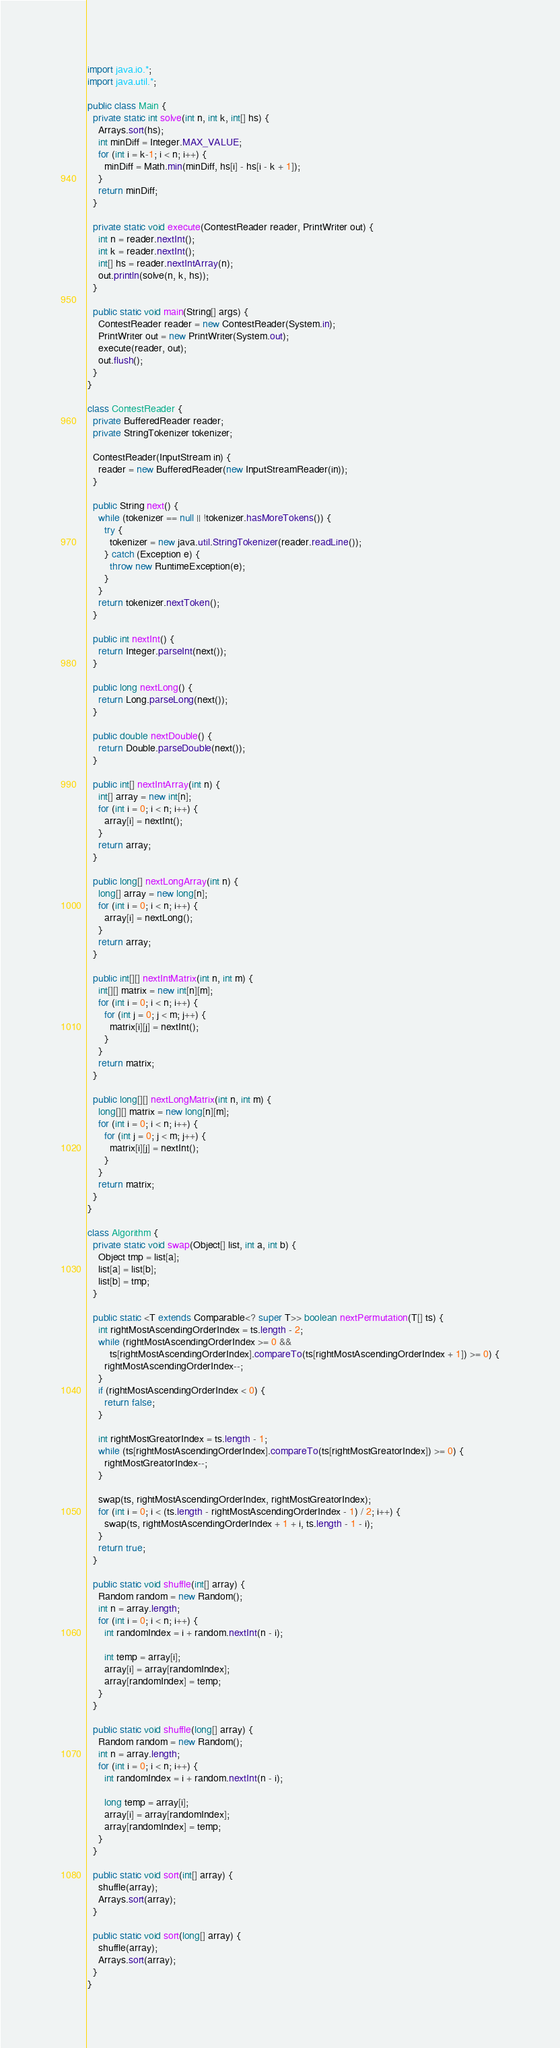Convert code to text. <code><loc_0><loc_0><loc_500><loc_500><_Java_>import java.io.*;
import java.util.*;

public class Main {
  private static int solve(int n, int k, int[] hs) {
    Arrays.sort(hs);
    int minDiff = Integer.MAX_VALUE;
    for (int i = k-1; i < n; i++) {
      minDiff = Math.min(minDiff, hs[i] - hs[i - k + 1]);
    }
    return minDiff;
  }
  
  private static void execute(ContestReader reader, PrintWriter out) {
    int n = reader.nextInt();
    int k = reader.nextInt();
    int[] hs = reader.nextIntArray(n);
    out.println(solve(n, k, hs));
  }
  
  public static void main(String[] args) {
    ContestReader reader = new ContestReader(System.in);
    PrintWriter out = new PrintWriter(System.out);
    execute(reader, out);
    out.flush();
  }
}

class ContestReader {
  private BufferedReader reader;
  private StringTokenizer tokenizer;
  
  ContestReader(InputStream in) {
    reader = new BufferedReader(new InputStreamReader(in));
  }
  
  public String next() {
    while (tokenizer == null || !tokenizer.hasMoreTokens()) {
      try {
        tokenizer = new java.util.StringTokenizer(reader.readLine());
      } catch (Exception e) {
        throw new RuntimeException(e);
      }
    }
    return tokenizer.nextToken();
  }
  
  public int nextInt() {
    return Integer.parseInt(next());
  }
  
  public long nextLong() {
    return Long.parseLong(next());
  }
  
  public double nextDouble() {
    return Double.parseDouble(next());
  }
  
  public int[] nextIntArray(int n) {
    int[] array = new int[n];
    for (int i = 0; i < n; i++) {
      array[i] = nextInt();
    }
    return array;
  }
  
  public long[] nextLongArray(int n) {
    long[] array = new long[n];
    for (int i = 0; i < n; i++) {
      array[i] = nextLong();
    }
    return array;
  }
  
  public int[][] nextIntMatrix(int n, int m) {
    int[][] matrix = new int[n][m];
    for (int i = 0; i < n; i++) {
      for (int j = 0; j < m; j++) {
        matrix[i][j] = nextInt();
      }
    }
    return matrix;
  }
  
  public long[][] nextLongMatrix(int n, int m) {
    long[][] matrix = new long[n][m];
    for (int i = 0; i < n; i++) {
      for (int j = 0; j < m; j++) {
        matrix[i][j] = nextInt();
      }
    }
    return matrix;
  }
}

class Algorithm {
  private static void swap(Object[] list, int a, int b) {
    Object tmp = list[a];
    list[a] = list[b];
    list[b] = tmp;
  }
  
  public static <T extends Comparable<? super T>> boolean nextPermutation(T[] ts) {
    int rightMostAscendingOrderIndex = ts.length - 2;
    while (rightMostAscendingOrderIndex >= 0 &&
        ts[rightMostAscendingOrderIndex].compareTo(ts[rightMostAscendingOrderIndex + 1]) >= 0) {
      rightMostAscendingOrderIndex--;
    }
    if (rightMostAscendingOrderIndex < 0) {
      return false;
    }
    
    int rightMostGreatorIndex = ts.length - 1;
    while (ts[rightMostAscendingOrderIndex].compareTo(ts[rightMostGreatorIndex]) >= 0) {
      rightMostGreatorIndex--;
    }
    
    swap(ts, rightMostAscendingOrderIndex, rightMostGreatorIndex);
    for (int i = 0; i < (ts.length - rightMostAscendingOrderIndex - 1) / 2; i++) {
      swap(ts, rightMostAscendingOrderIndex + 1 + i, ts.length - 1 - i);
    }
    return true;
  }
  
  public static void shuffle(int[] array) {
    Random random = new Random();
    int n = array.length;
    for (int i = 0; i < n; i++) {
      int randomIndex = i + random.nextInt(n - i);
      
      int temp = array[i];
      array[i] = array[randomIndex];
      array[randomIndex] = temp;
    }
  }
  
  public static void shuffle(long[] array) {
    Random random = new Random();
    int n = array.length;
    for (int i = 0; i < n; i++) {
      int randomIndex = i + random.nextInt(n - i);
      
      long temp = array[i];
      array[i] = array[randomIndex];
      array[randomIndex] = temp;
    }
  }
  
  public static void sort(int[] array) {
    shuffle(array);
    Arrays.sort(array);
  }
  
  public static void sort(long[] array) {
    shuffle(array);
    Arrays.sort(array);
  }
}

</code> 